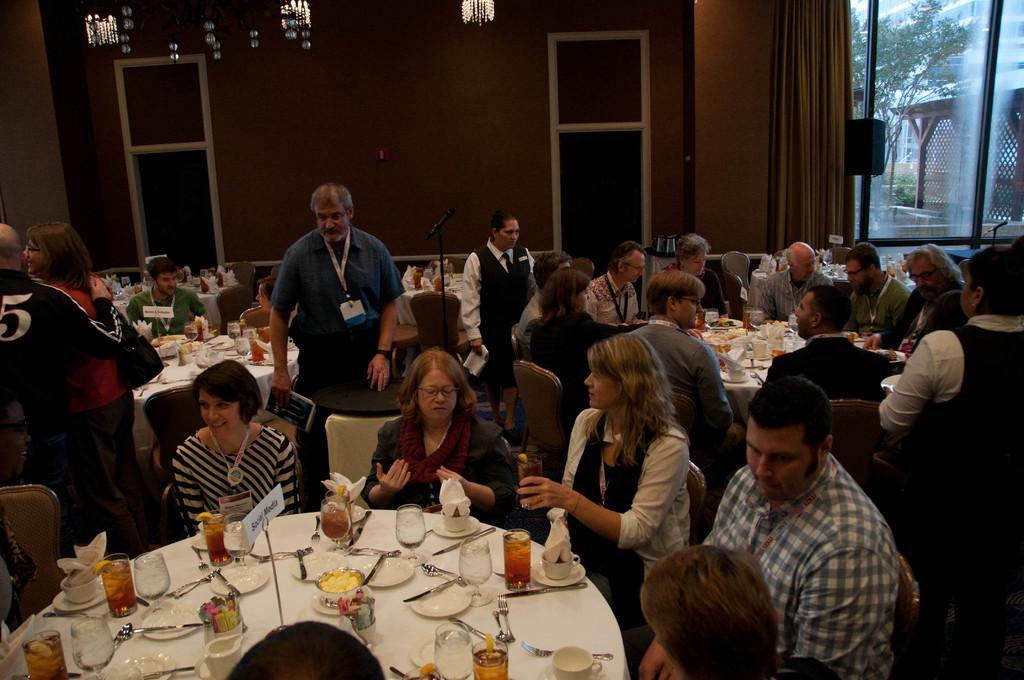In one or two sentences, can you explain what this image depicts? In this image we can see these people are sitting on the chairs near the tables where glasses, plates, knives, forks and few more things are kept on it. Here we can see these people are standing. In the background, we can see the wall, curtains, speaker box and glass windows through which we can see pergola and trees. 